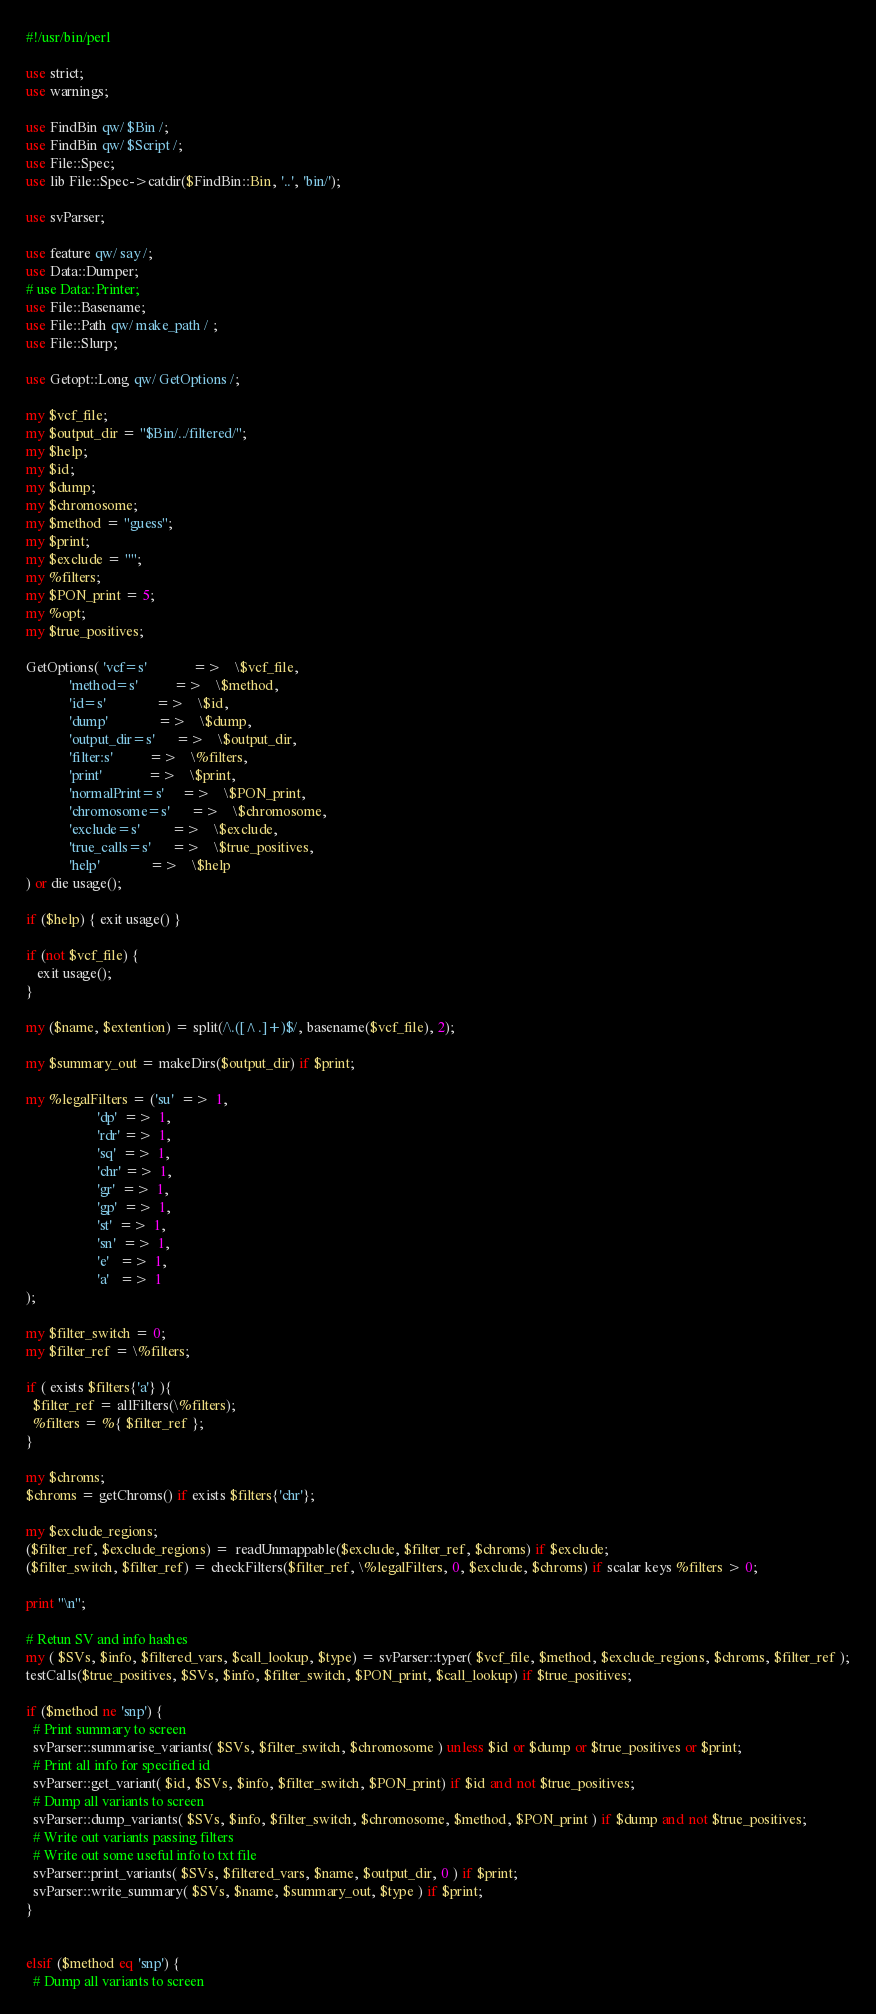Convert code to text. <code><loc_0><loc_0><loc_500><loc_500><_Perl_>#!/usr/bin/perl

use strict;
use warnings;

use FindBin qw/ $Bin /;
use FindBin qw/ $Script /;
use File::Spec;
use lib File::Spec->catdir($FindBin::Bin, '..', 'bin/');

use svParser;

use feature qw/ say /;
use Data::Dumper;
# use Data::Printer;
use File::Basename;
use File::Path qw/ make_path / ;
use File::Slurp;

use Getopt::Long qw/ GetOptions /;

my $vcf_file;
my $output_dir = "$Bin/../filtered/";
my $help;
my $id;
my $dump;
my $chromosome;
my $method = "guess";
my $print;
my $exclude = "";
my %filters;
my $PON_print = 5;
my %opt;
my $true_positives;

GetOptions( 'vcf=s'             =>    \$vcf_file,
            'method=s'          =>    \$method,
            'id=s'              =>    \$id,
            'dump'              =>    \$dump,
            'output_dir=s'      =>    \$output_dir,
            'filter:s'          =>    \%filters,
            'print'             =>    \$print,
            'normalPrint=s'     =>    \$PON_print,
            'chromosome=s'      =>    \$chromosome,
            'exclude=s'         =>    \$exclude,
            'true_calls=s'      =>    \$true_positives,
            'help'              =>    \$help
) or die usage();

if ($help) { exit usage() }

if (not $vcf_file) {
   exit usage();
}

my ($name, $extention) = split(/\.([^.]+)$/, basename($vcf_file), 2);

my $summary_out = makeDirs($output_dir) if $print;

my %legalFilters = ('su'  =>  1,
                    'dp'  =>  1,
                    'rdr' =>  1,
                    'sq'  =>  1,
                    'chr' =>  1,
                    'gr'  =>  1,
                    'gp'  =>  1,
                    'st'  =>  1,
                    'sn'  =>  1,
                    'e'   =>  1,
                    'a'   =>  1
);

my $filter_switch = 0;
my $filter_ref = \%filters;

if ( exists $filters{'a'} ){
  $filter_ref = allFilters(\%filters);
  %filters = %{ $filter_ref };
}

my $chroms;
$chroms = getChroms() if exists $filters{'chr'};

my $exclude_regions;
($filter_ref, $exclude_regions) =  readUnmappable($exclude, $filter_ref, $chroms) if $exclude;
($filter_switch, $filter_ref) = checkFilters($filter_ref, \%legalFilters, 0, $exclude, $chroms) if scalar keys %filters > 0;

print "\n";

# Retun SV and info hashes
my ( $SVs, $info, $filtered_vars, $call_lookup, $type) = svParser::typer( $vcf_file, $method, $exclude_regions, $chroms, $filter_ref );
testCalls($true_positives, $SVs, $info, $filter_switch, $PON_print, $call_lookup) if $true_positives;

if ($method ne 'snp') {
  # Print summary to screen
  svParser::summarise_variants( $SVs, $filter_switch, $chromosome ) unless $id or $dump or $true_positives or $print;
  # Print all info for specified id
  svParser::get_variant( $id, $SVs, $info, $filter_switch, $PON_print) if $id and not $true_positives;
  # Dump all variants to screen
  svParser::dump_variants( $SVs, $info, $filter_switch, $chromosome, $method, $PON_print ) if $dump and not $true_positives;
  # Write out variants passing filters
  # Write out some useful info to txt file
  svParser::print_variants( $SVs, $filtered_vars, $name, $output_dir, 0 ) if $print;
  svParser::write_summary( $SVs, $name, $summary_out, $type ) if $print;
}


elsif ($method eq 'snp') {
  # Dump all variants to screen</code> 